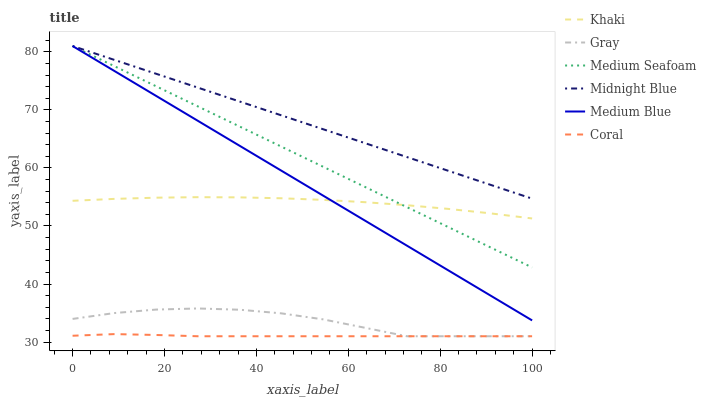Does Coral have the minimum area under the curve?
Answer yes or no. Yes. Does Midnight Blue have the maximum area under the curve?
Answer yes or no. Yes. Does Khaki have the minimum area under the curve?
Answer yes or no. No. Does Khaki have the maximum area under the curve?
Answer yes or no. No. Is Medium Blue the smoothest?
Answer yes or no. Yes. Is Gray the roughest?
Answer yes or no. Yes. Is Khaki the smoothest?
Answer yes or no. No. Is Khaki the roughest?
Answer yes or no. No. Does Gray have the lowest value?
Answer yes or no. Yes. Does Khaki have the lowest value?
Answer yes or no. No. Does Medium Seafoam have the highest value?
Answer yes or no. Yes. Does Khaki have the highest value?
Answer yes or no. No. Is Coral less than Medium Seafoam?
Answer yes or no. Yes. Is Midnight Blue greater than Gray?
Answer yes or no. Yes. Does Medium Seafoam intersect Khaki?
Answer yes or no. Yes. Is Medium Seafoam less than Khaki?
Answer yes or no. No. Is Medium Seafoam greater than Khaki?
Answer yes or no. No. Does Coral intersect Medium Seafoam?
Answer yes or no. No. 